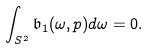Convert formula to latex. <formula><loc_0><loc_0><loc_500><loc_500>\int _ { S ^ { 2 } } \mathfrak { b } _ { 1 } ( \omega , p ) d \omega = 0 .</formula> 